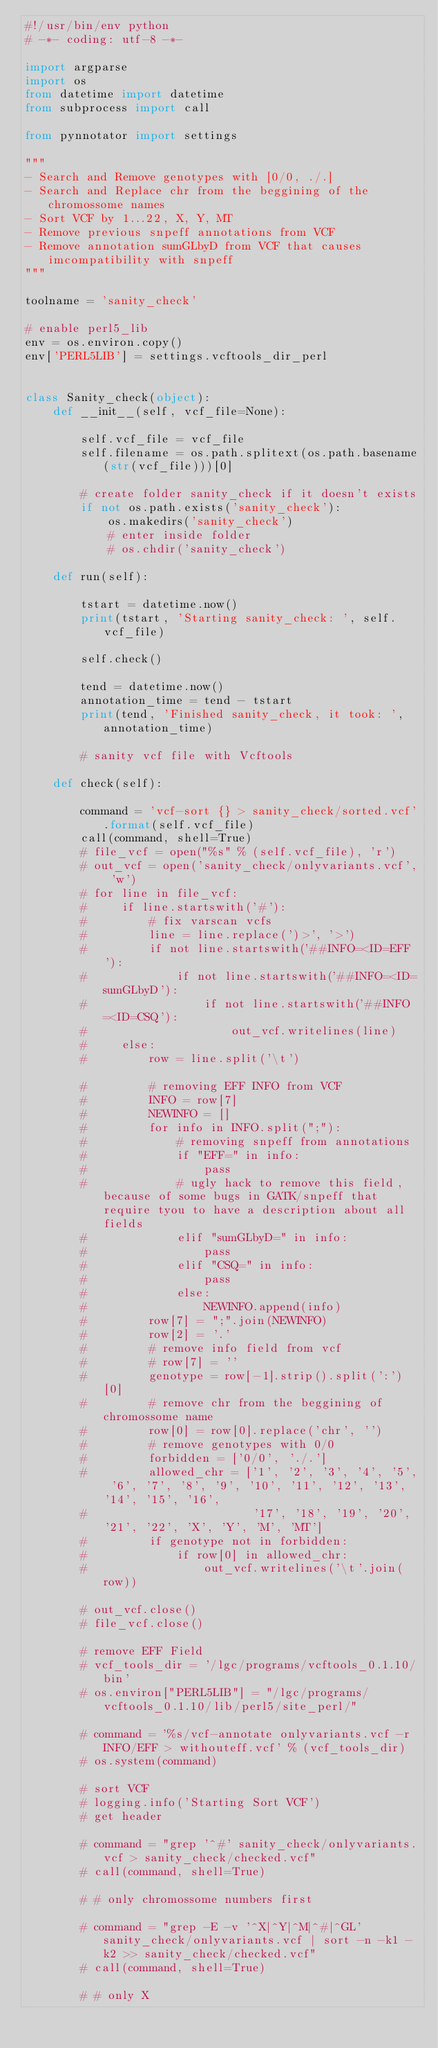<code> <loc_0><loc_0><loc_500><loc_500><_Python_>#!/usr/bin/env python
# -*- coding: utf-8 -*-

import argparse
import os
from datetime import datetime
from subprocess import call

from pynnotator import settings

"""
- Search and Remove genotypes with [0/0, ./.]
- Search and Replace chr from the beggining of the chromossome names
- Sort VCF by 1...22, X, Y, MT
- Remove previous snpeff annotations from VCF
- Remove annotation sumGLbyD from VCF that causes imcompatibility with snpeff
"""

toolname = 'sanity_check'

# enable perl5_lib
env = os.environ.copy()
env['PERL5LIB'] = settings.vcftools_dir_perl


class Sanity_check(object):
    def __init__(self, vcf_file=None):

        self.vcf_file = vcf_file
        self.filename = os.path.splitext(os.path.basename(str(vcf_file)))[0]

        # create folder sanity_check if it doesn't exists
        if not os.path.exists('sanity_check'):
            os.makedirs('sanity_check')
            # enter inside folder
            # os.chdir('sanity_check')

    def run(self):

        tstart = datetime.now()
        print(tstart, 'Starting sanity_check: ', self.vcf_file)

        self.check()

        tend = datetime.now()
        annotation_time = tend - tstart
        print(tend, 'Finished sanity_check, it took: ', annotation_time)

        # sanity vcf file with Vcftools

    def check(self):

        command = 'vcf-sort {} > sanity_check/sorted.vcf'.format(self.vcf_file)
        call(command, shell=True)
        # file_vcf = open("%s" % (self.vcf_file), 'r')
        # out_vcf = open('sanity_check/onlyvariants.vcf', 'w')
        # for line in file_vcf:
        #     if line.startswith('#'):
        #         # fix varscan vcfs            
        #         line = line.replace(')>', '>')
        #         if not line.startswith('##INFO=<ID=EFF'):
        #             if not line.startswith('##INFO=<ID=sumGLbyD'):
        #                 if not line.startswith('##INFO=<ID=CSQ'):
        #                     out_vcf.writelines(line)
        #     else:
        #         row = line.split('\t')

        #         # removing EFF INFO from VCF
        #         INFO = row[7]
        #         NEWINFO = []
        #         for info in INFO.split(";"):
        #             # removing snpeff from annotations
        #             if "EFF=" in info:
        #                 pass
        #             # ugly hack to remove this field, because of some bugs in GATK/snpeff that require tyou to have a description about all fields
        #             elif "sumGLbyD=" in info:
        #                 pass
        #             elif "CSQ=" in info:
        #                 pass
        #             else:
        #                 NEWINFO.append(info)
        #         row[7] = ";".join(NEWINFO)
        #         row[2] = '.'
        #         # remove info field from vcf
        #         # row[7] = ''
        #         genotype = row[-1].strip().split(':')[0]
        #         # remove chr from the beggining of chromossome name
        #         row[0] = row[0].replace('chr', '')
        #         # remove genotypes with 0/0
        #         forbidden = ['0/0', './.']
        #         allowed_chr = ['1', '2', '3', '4', '5', '6', '7', '8', '9', '10', '11', '12', '13', '14', '15', '16',
        #                        '17', '18', '19', '20', '21', '22', 'X', 'Y', 'M', 'MT']
        #         if genotype not in forbidden:
        #             if row[0] in allowed_chr:
        #                 out_vcf.writelines('\t'.join(row))

        # out_vcf.close()
        # file_vcf.close()

        # remove EFF Field
        # vcf_tools_dir = '/lgc/programs/vcftools_0.1.10/bin'
        # os.environ["PERL5LIB"] = "/lgc/programs/vcftools_0.1.10/lib/perl5/site_perl/"

        # command = '%s/vcf-annotate onlyvariants.vcf -r INFO/EFF > withouteff.vcf' % (vcf_tools_dir)
        # os.system(command)

        # sort VCF
        # logging.info('Starting Sort VCF')
        # get header

        # command = "grep '^#' sanity_check/onlyvariants.vcf > sanity_check/checked.vcf"
        # call(command, shell=True)

        # # only chromossome numbers first

        # command = "grep -E -v '^X|^Y|^M|^#|^GL' sanity_check/onlyvariants.vcf | sort -n -k1 -k2 >> sanity_check/checked.vcf"
        # call(command, shell=True)

        # # only X</code> 